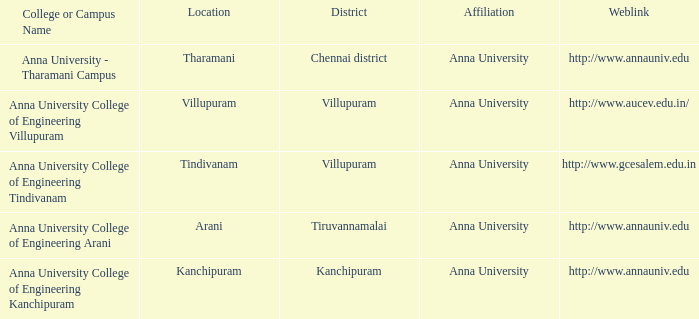What site hosts a college or campus titled anna university - tharamani campus? Tharamani. 